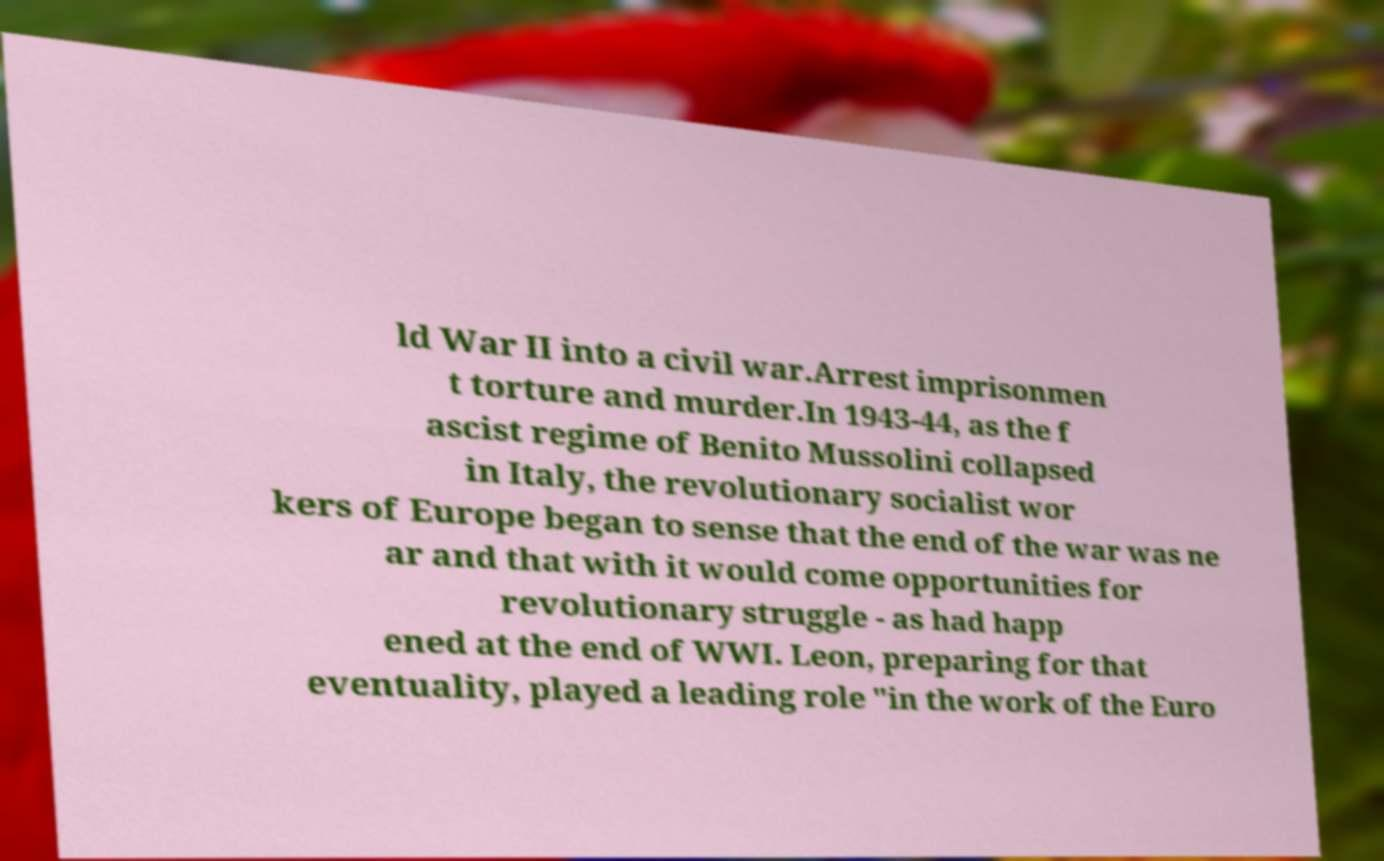Please identify and transcribe the text found in this image. ld War II into a civil war.Arrest imprisonmen t torture and murder.In 1943-44, as the f ascist regime of Benito Mussolini collapsed in Italy, the revolutionary socialist wor kers of Europe began to sense that the end of the war was ne ar and that with it would come opportunities for revolutionary struggle - as had happ ened at the end of WWI. Leon, preparing for that eventuality, played a leading role "in the work of the Euro 